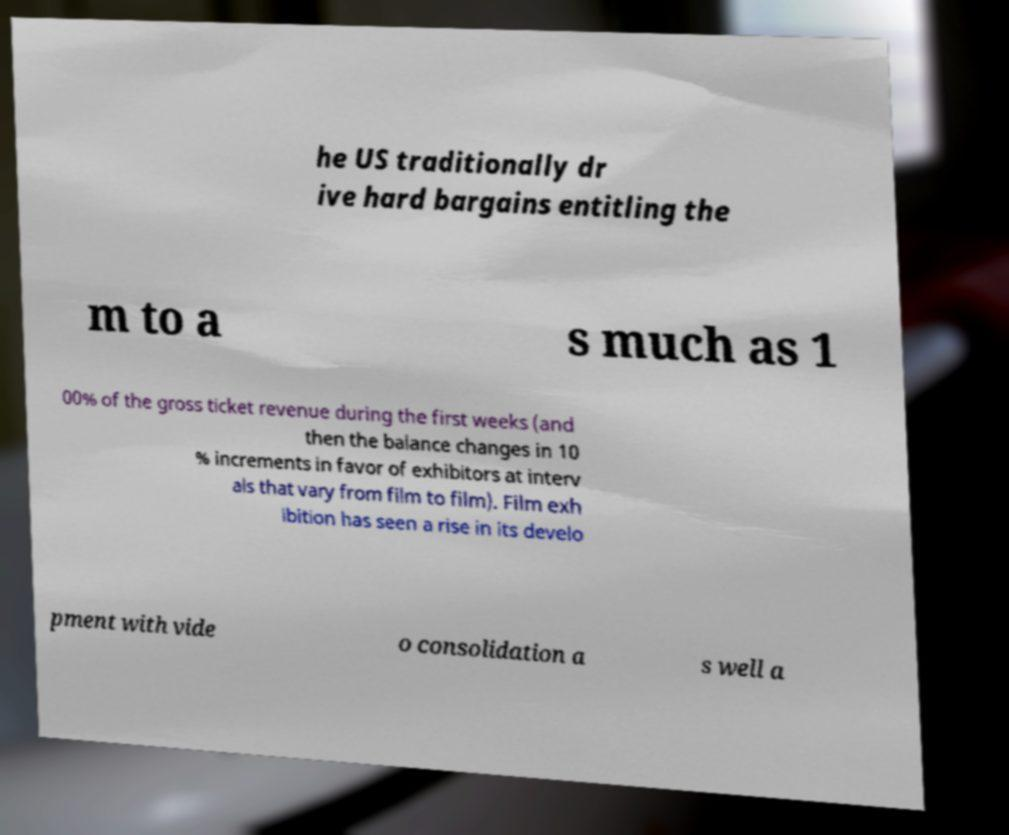For documentation purposes, I need the text within this image transcribed. Could you provide that? he US traditionally dr ive hard bargains entitling the m to a s much as 1 00% of the gross ticket revenue during the first weeks (and then the balance changes in 10 % increments in favor of exhibitors at interv als that vary from film to film). Film exh ibition has seen a rise in its develo pment with vide o consolidation a s well a 